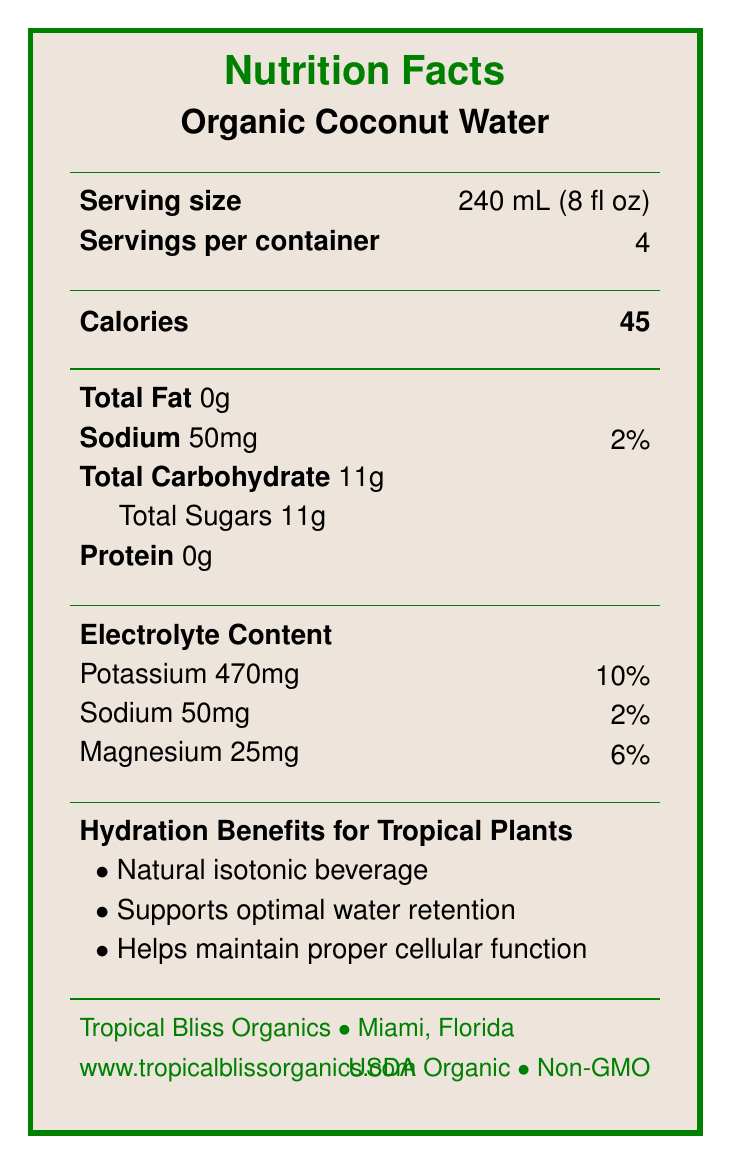What is the serving size for Organic Coconut Water? The document states that the serving size is 240 mL (8 fl oz).
Answer: 240 mL (8 fl oz) How many servings per container are there for the Organic Coconut Water? The document specifies that there are 4 servings per container.
Answer: 4 How many calories are there per serving in Organic Coconut Water? The document lists that there are 45 calories per serving.
Answer: 45 What is the potassium content per serving in Organic Coconut Water? The document indicates that each serving contains 470mg of potassium.
Answer: 470mg What are the hydration benefits for tropical plants from using Organic Coconut Water? The document lists three hydration benefits for tropical plants: it is a natural isotonic beverage, supports optimal water retention, and helps maintain proper cellular function.
Answer: Natural isotonic beverage, Supports optimal water retention, Helps maintain proper cellular function What percentage of the daily value of potassium does one serving of Organic Coconut Water provide? A. 5% B. 10% C. 15% D. 20% The document states that one serving of Organic Coconut Water provides 10% of the daily value for potassium.
Answer: B. 10% Which nutrient is present in the smallest amount per serving in Organic Coconut Water? A. Sodium B. Magnesium C. Calcium D. Phosphorus The document shows that phosphorus is present in the smallest amount (20mg) per serving.
Answer: D. Phosphorus Is the Organic Coconut Water sourced from organic farms? The document mentions that the coconut water is sourced from organic coconut farms in Thailand.
Answer: Yes Summarize the main idea of the document related to Organic Coconut Water. The explanation is a summary of the key details from the document, covering nutrition facts, plant benefits, usage instructions, and additional product information.
Answer: The document provides the nutritional details, hydration benefits, and electrolyte content of Organic Coconut Water, emphasizing its benefits for tropical plants. It also includes serving size, servings per container, and nutrient breakdown, along with sustainability and certification information from Tropical Bliss Organics. How should Organic Coconut Water be stored after opening? The document recommends refrigerating the coconut water after opening and consuming it within 3-5 days.
Answer: Refrigerate after opening and consume within 3-5 days What is the calorie content for an entire container of Organic Coconut Water? Since there are 4 servings per container and each serving has 45 calories, the total is 4 x 45 = 180 calories.
Answer: 180 calories What is the expiration date of the Organic Coconut Water? The document does not provide any information on the expiration date of the product.
Answer: Not enough information 